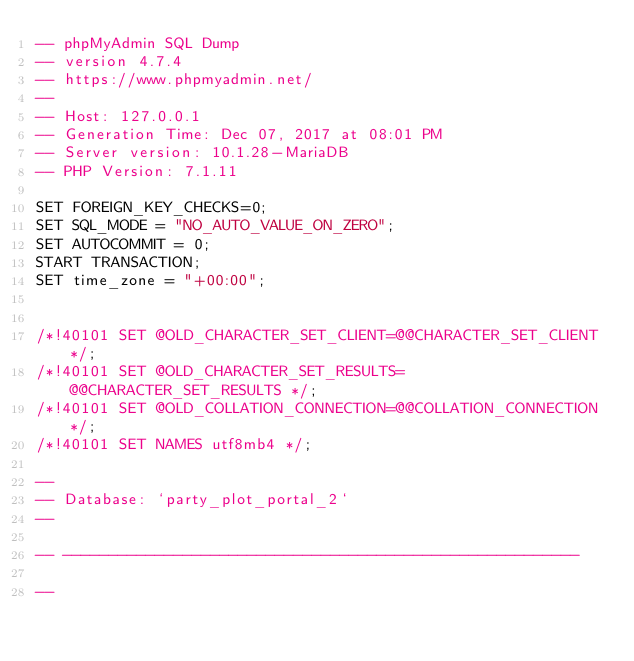<code> <loc_0><loc_0><loc_500><loc_500><_SQL_>-- phpMyAdmin SQL Dump
-- version 4.7.4
-- https://www.phpmyadmin.net/
--
-- Host: 127.0.0.1
-- Generation Time: Dec 07, 2017 at 08:01 PM
-- Server version: 10.1.28-MariaDB
-- PHP Version: 7.1.11

SET FOREIGN_KEY_CHECKS=0;
SET SQL_MODE = "NO_AUTO_VALUE_ON_ZERO";
SET AUTOCOMMIT = 0;
START TRANSACTION;
SET time_zone = "+00:00";


/*!40101 SET @OLD_CHARACTER_SET_CLIENT=@@CHARACTER_SET_CLIENT */;
/*!40101 SET @OLD_CHARACTER_SET_RESULTS=@@CHARACTER_SET_RESULTS */;
/*!40101 SET @OLD_COLLATION_CONNECTION=@@COLLATION_CONNECTION */;
/*!40101 SET NAMES utf8mb4 */;

--
-- Database: `party_plot_portal_2`
--

-- --------------------------------------------------------

--</code> 